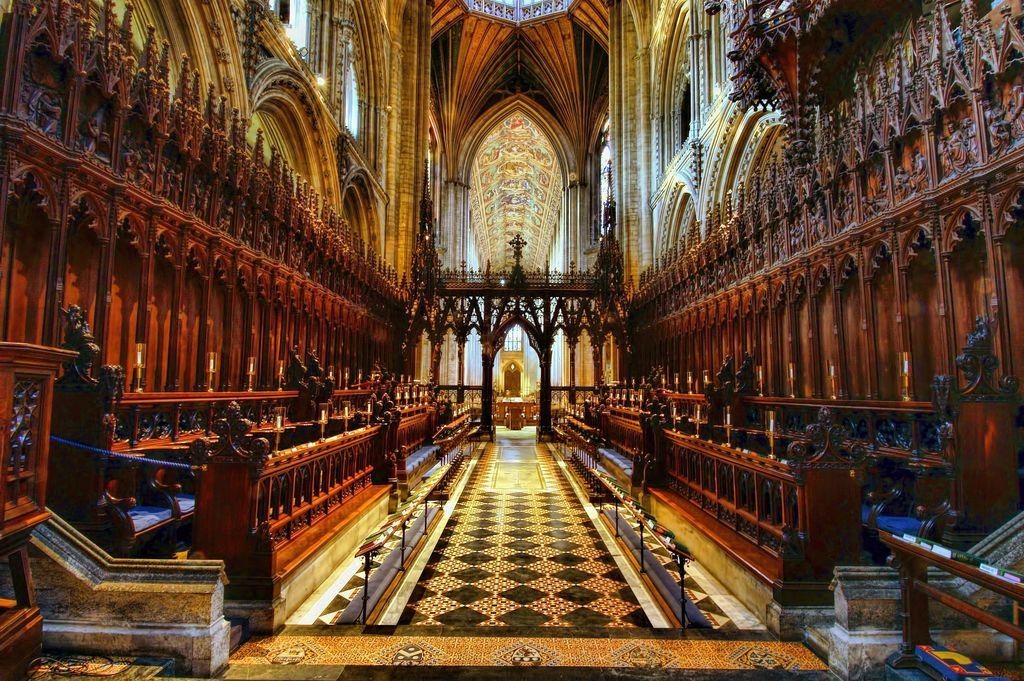What type of location is depicted in the image? The image shows an inside view of a building. What is one of the main architectural features of the building? There is a floor in the image. What type of furniture can be seen in the image? Chairs are present in the image. What is the purpose of the rope in the image? The purpose of the rope is not clear from the image, but it is visible. What are the pillars used for in the image? The pillars provide support to the structure of the building. What are the poles used for in the image? The poles may also provide support to the structure of the building or serve as a decorative element. What is the shape of the arch in the image? The shape of the arch is not clear from the image, but it is visible. What is the design pattern on the wall in the image? The wall has a designed pattern. What is visible above the floor in the image? The ceiling is visible in the image. How quiet is the town in the image? There is no town present in the image; it shows an inside view of a building. 